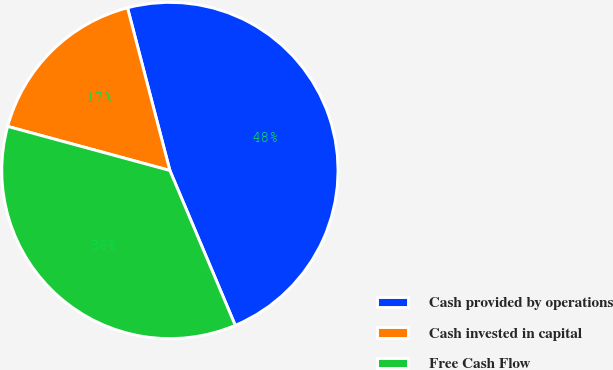Convert chart. <chart><loc_0><loc_0><loc_500><loc_500><pie_chart><fcel>Cash provided by operations<fcel>Cash invested in capital<fcel>Free Cash Flow<nl><fcel>47.7%<fcel>16.72%<fcel>35.58%<nl></chart> 